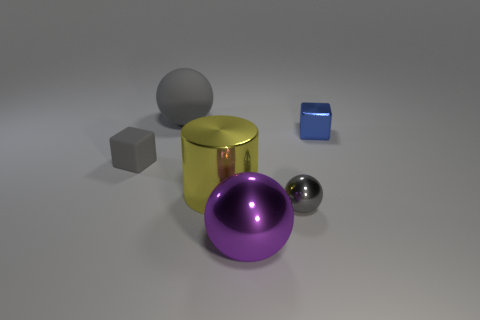Subtract all metal spheres. How many spheres are left? 1 Add 3 shiny cylinders. How many objects exist? 9 Subtract all cylinders. How many objects are left? 5 Add 1 small matte objects. How many small matte objects exist? 2 Subtract 0 gray cylinders. How many objects are left? 6 Subtract all purple matte cylinders. Subtract all balls. How many objects are left? 3 Add 3 small gray spheres. How many small gray spheres are left? 4 